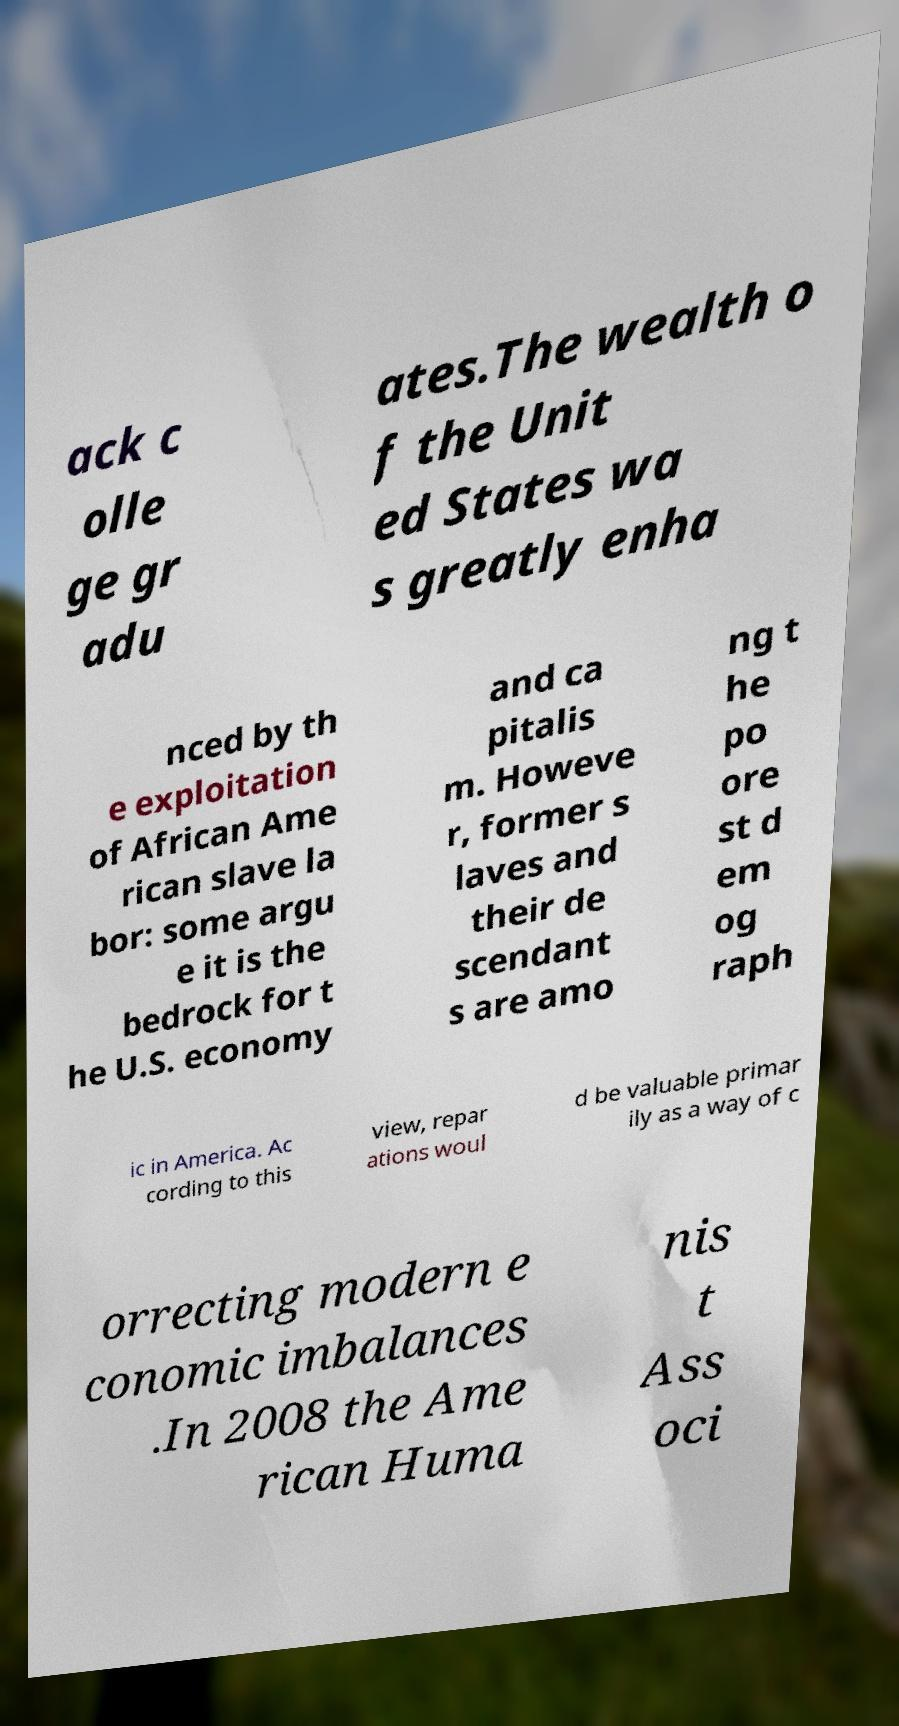Can you read and provide the text displayed in the image?This photo seems to have some interesting text. Can you extract and type it out for me? ack c olle ge gr adu ates.The wealth o f the Unit ed States wa s greatly enha nced by th e exploitation of African Ame rican slave la bor: some argu e it is the bedrock for t he U.S. economy and ca pitalis m. Howeve r, former s laves and their de scendant s are amo ng t he po ore st d em og raph ic in America. Ac cording to this view, repar ations woul d be valuable primar ily as a way of c orrecting modern e conomic imbalances .In 2008 the Ame rican Huma nis t Ass oci 